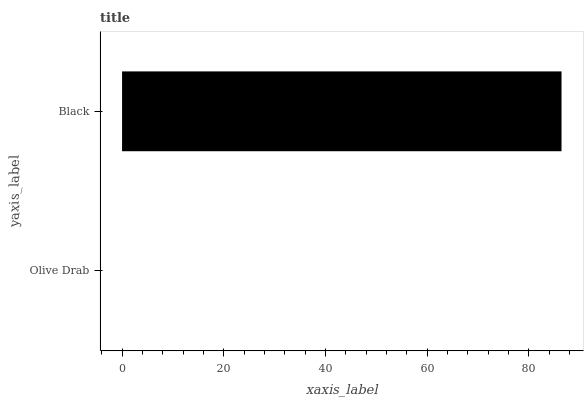Is Olive Drab the minimum?
Answer yes or no. Yes. Is Black the maximum?
Answer yes or no. Yes. Is Black the minimum?
Answer yes or no. No. Is Black greater than Olive Drab?
Answer yes or no. Yes. Is Olive Drab less than Black?
Answer yes or no. Yes. Is Olive Drab greater than Black?
Answer yes or no. No. Is Black less than Olive Drab?
Answer yes or no. No. Is Black the high median?
Answer yes or no. Yes. Is Olive Drab the low median?
Answer yes or no. Yes. Is Olive Drab the high median?
Answer yes or no. No. Is Black the low median?
Answer yes or no. No. 